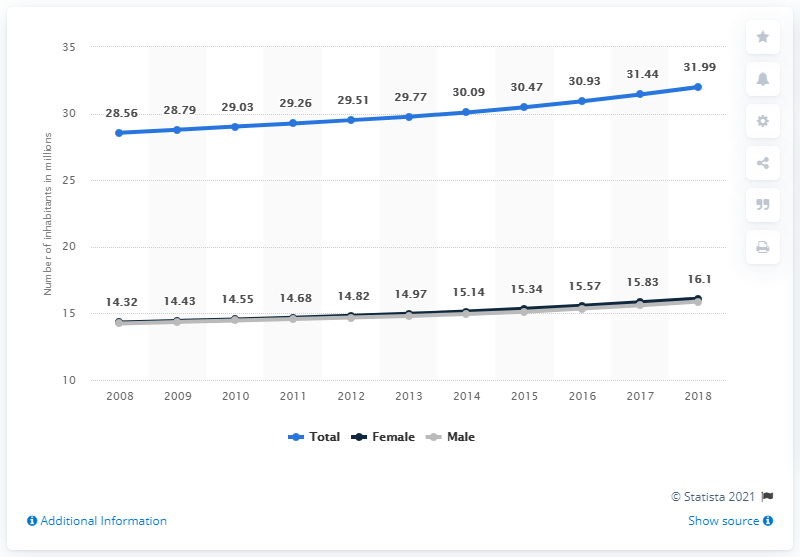Identify some key points in this picture. The total population of Peru for males from 2017 to 2018 was 31.93 million inhabitants. The population of Peru began to show an upward trend in the year 2008. The population of Peru in 2018 was 31.99 million. The total population of Peru in 2009 was approximately 28.79 million, broken down by gender. 